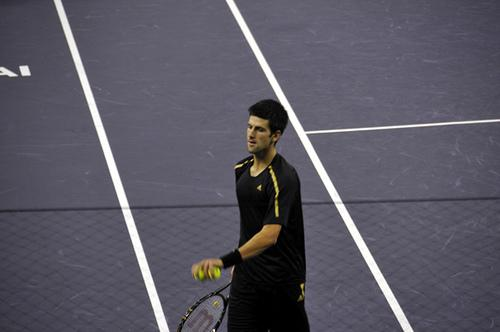What is the person holding in their hands? tennis balls 